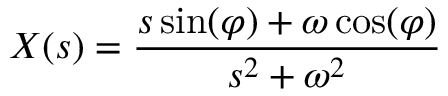Convert formula to latex. <formula><loc_0><loc_0><loc_500><loc_500>X ( s ) = { \frac { s \sin ( \varphi ) + \omega \cos ( \varphi ) } { s ^ { 2 } + \omega ^ { 2 } } }</formula> 